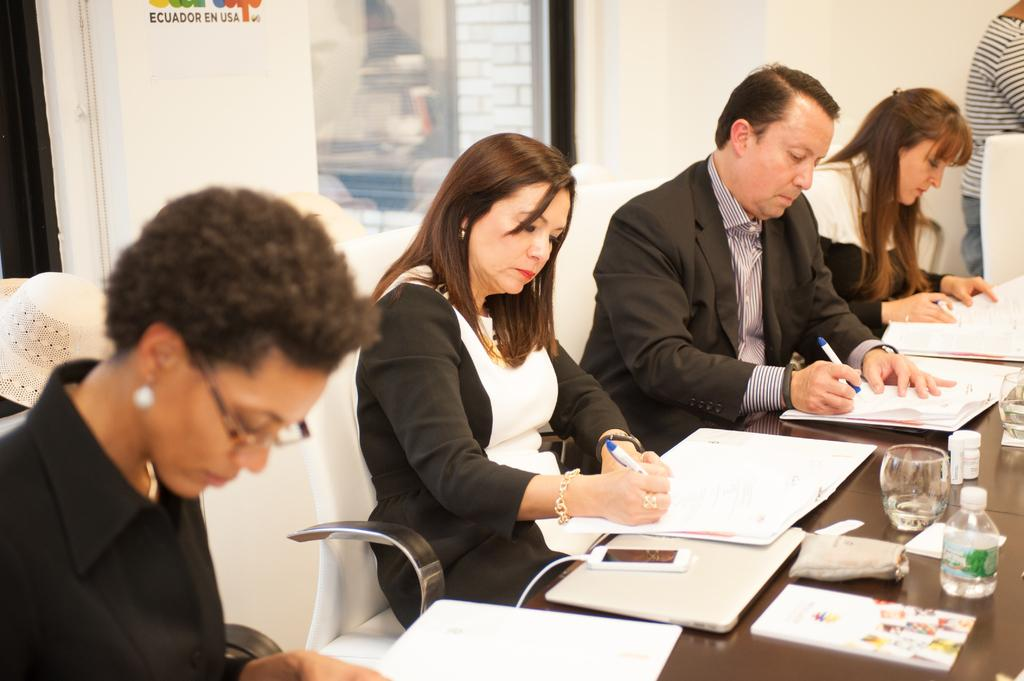How many people are present in the image? There are people in the image, but the exact number cannot be determined from the provided facts. What type of furniture is visible in the image? There are chairs and a table in the image. What items might be used for writing in the image? There are pens in the image. What objects might be used for drinking in the image? There are glasses and a bottle in the image. What items might be used for reading in the image? There are books in the image. What type of communication device is present in the image? There is a mobile in the image. What can be seen in the background of the image? There is a wall and a window in the background of the image. How many tomatoes are visible on the table in the image? There is no mention of tomatoes in the provided facts, so we cannot determine if any are present in the image. Is there a stream visible in the background of the image? There is no mention of a stream in the provided facts, so we cannot determine if one is present in the image. 